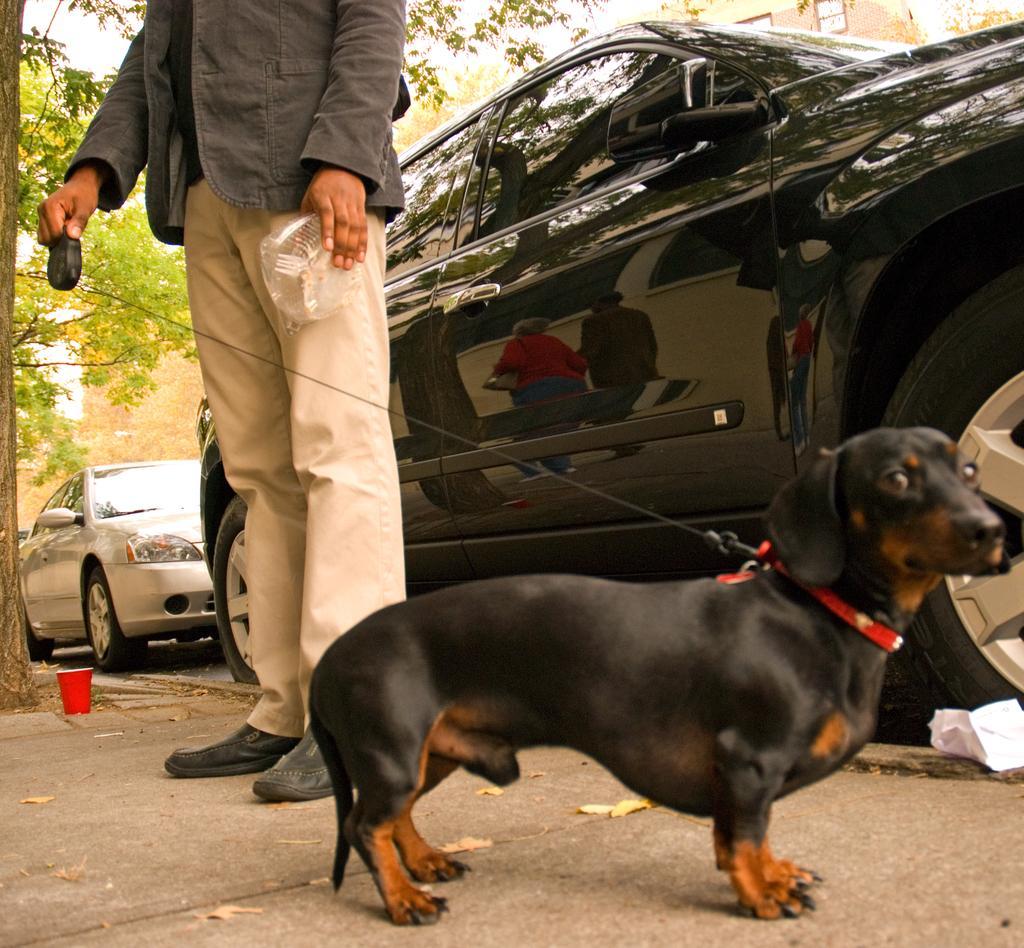In one or two sentences, can you explain what this image depicts? In this picture there is a black dog standing on the road with a man catching it with a wire. In the background we observe two cars. 